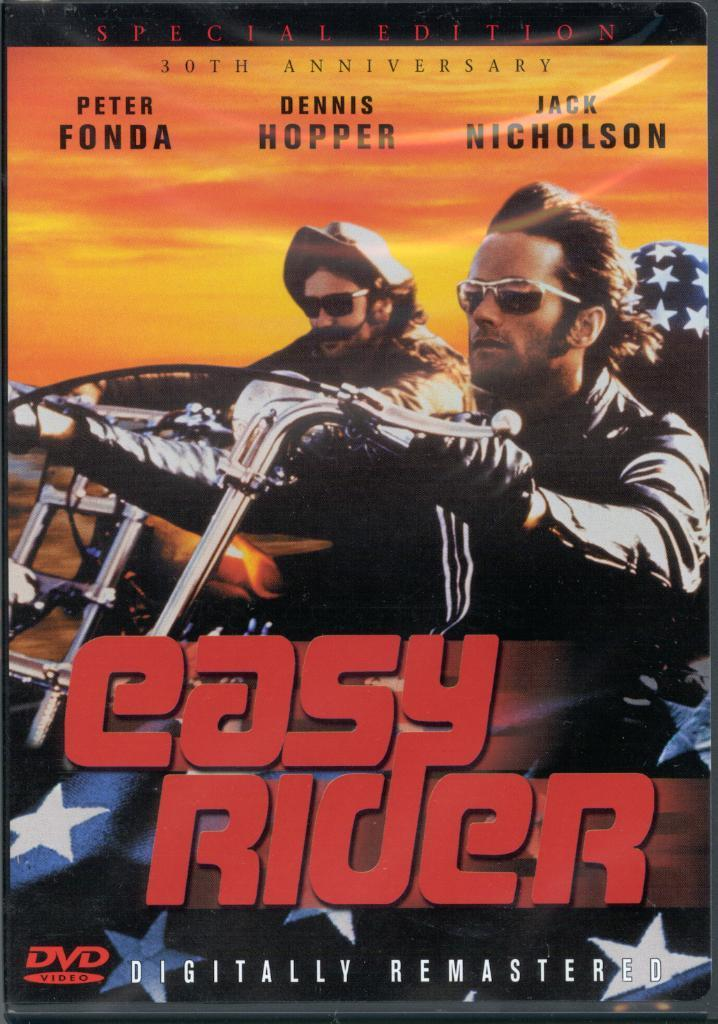<image>
Describe the image concisely. A DVD cover for Easy Rider features two men on motorcycles. 